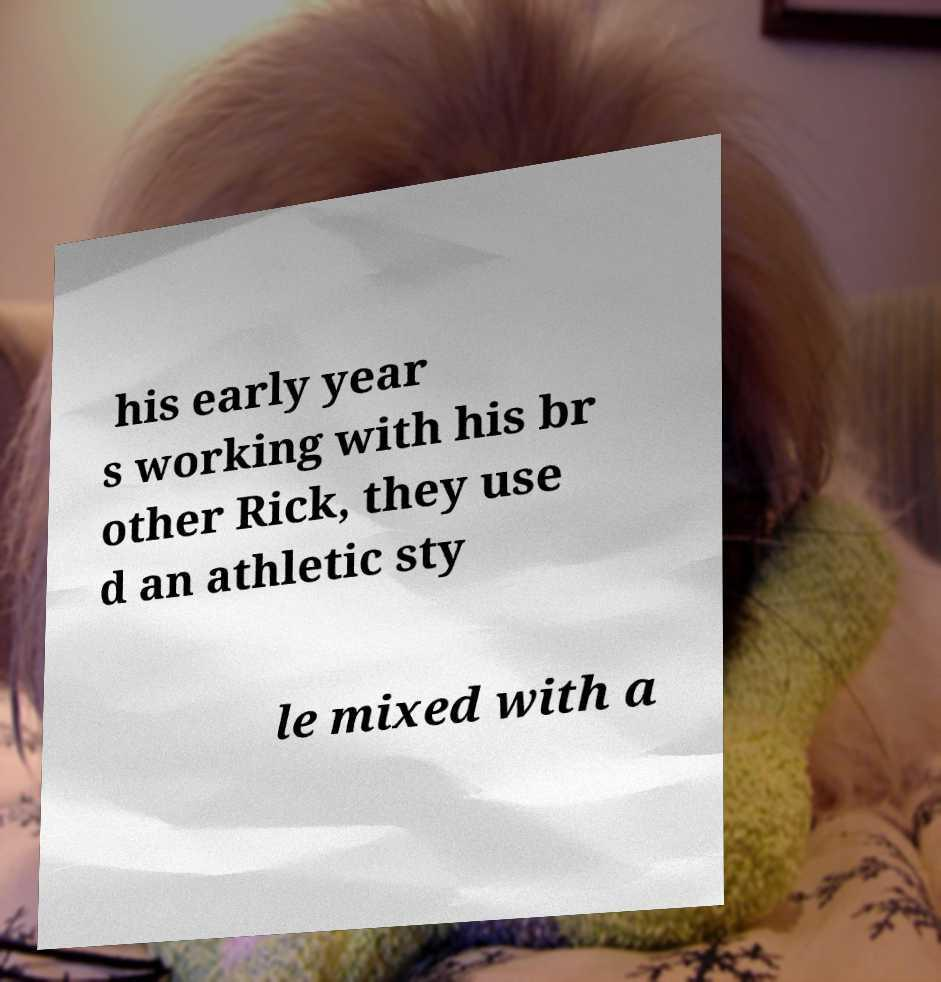For documentation purposes, I need the text within this image transcribed. Could you provide that? his early year s working with his br other Rick, they use d an athletic sty le mixed with a 